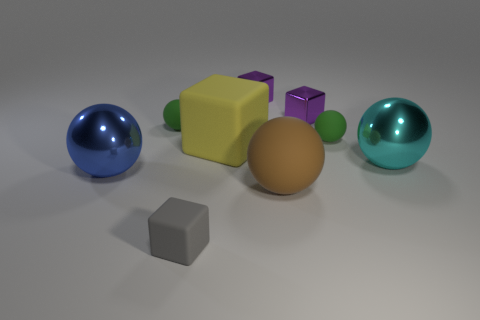Are there an equal number of cyan metallic objects that are behind the big cyan metallic sphere and blue shiny objects left of the large yellow block?
Your answer should be very brief. No. How many other objects are the same material as the cyan object?
Your answer should be compact. 3. How many small things are purple matte blocks or green objects?
Give a very brief answer. 2. Are there an equal number of tiny green rubber balls that are in front of the blue shiny ball and big blue metal objects?
Provide a short and direct response. No. There is a rubber cube that is behind the large blue shiny object; is there a small purple cube in front of it?
Your response must be concise. No. The large block has what color?
Give a very brief answer. Yellow. There is a rubber thing that is to the left of the yellow matte thing and behind the gray object; what size is it?
Make the answer very short. Small. How many objects are either big metallic things to the right of the big yellow thing or brown matte balls?
Offer a very short reply. 2. The brown thing that is the same material as the small gray cube is what shape?
Offer a very short reply. Sphere. The brown object has what shape?
Make the answer very short. Sphere. 